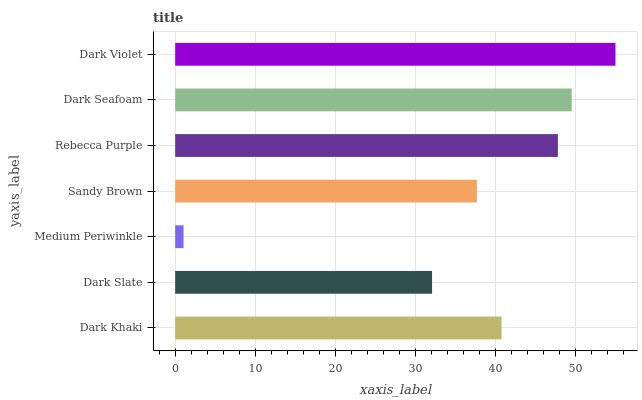Is Medium Periwinkle the minimum?
Answer yes or no. Yes. Is Dark Violet the maximum?
Answer yes or no. Yes. Is Dark Slate the minimum?
Answer yes or no. No. Is Dark Slate the maximum?
Answer yes or no. No. Is Dark Khaki greater than Dark Slate?
Answer yes or no. Yes. Is Dark Slate less than Dark Khaki?
Answer yes or no. Yes. Is Dark Slate greater than Dark Khaki?
Answer yes or no. No. Is Dark Khaki less than Dark Slate?
Answer yes or no. No. Is Dark Khaki the high median?
Answer yes or no. Yes. Is Dark Khaki the low median?
Answer yes or no. Yes. Is Sandy Brown the high median?
Answer yes or no. No. Is Dark Slate the low median?
Answer yes or no. No. 